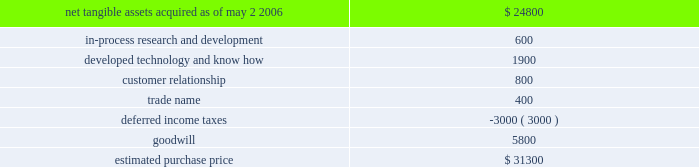Hologic , inc .
Notes to consolidated financial statements ( continued ) ( in thousands , except per share data ) its supply chain and improve manufacturing margins .
The combination of the companies should also facilitate further manufacturing efficiencies and accelerate research and development of new detector products .
Aeg was a privately held group of companies headquartered in warstein , germany , with manufacturing operations in germany , china and the united states .
The aggregate purchase price for aeg was approximately $ 31300 ( subject to adjustment ) consisting of eur $ 24100 in cash and 110 shares of hologic common stock valued at $ 5300 , and approximately $ 1900 for acquisition related fees and expenses .
The company determined the fair value of the shares issued in connection with the acquisition in accordance with eitf issue no .
99-12 , determination of the measurement date for the market price of acquirer securities issued in a purchase business combination .
These 110 shares were subject to contingent put options pursuant to which the holders had the option to resell the shares to the company during a period of one year following the completion of the acquisition if the closing price of the company 2019s stock falls and remains below a threshold price .
The put options were never exercised and expired on may 2 , 2007 .
The acquisition also provided for a one-year earn out of eur 1700 ( approximately $ 2000 usd ) which was payable in cash if aeg calendar year 2006 earnings , as defined , exceeded a pre-determined amount .
Aeg 2019s 2006 earnings did not exceed such pre-determined amounts and no payment was made .
The components and allocation of the purchase price , consists of the following approximate amounts: .
The company implemented a plan to restructure certain of aeg 2019s historical activities .
The company originally recorded a liability of approximately $ 2100 in accordance with eitf issue no .
95-3 , recognition of liabilities in connection with a purchase business combination , related to the termination of certain employees under this plan .
Upon completion of the plan in fiscal 2007 the company reduced this liability by approximately $ 241 with a corresponding reduction in goodwill .
All amounts have been paid as of september 29 , 2007 .
As part of the aeg acquisition the company acquired a minority interest in the equity securities of a private german company .
The company estimated the fair value of these securities to be approximately $ 1400 in its original purchase price allocation .
During the year ended september 29 , 2007 , the company sold these securities for proceeds of approximately $ 2150 .
The difference of approximately $ 750 between the preliminary fair value estimate and proceeds upon sale has been recorded as a reduction of goodwill .
The final purchase price allocations were completed within one year of the acquisition and the adjustments did not have a material impact on the company 2019s financial position or results of operations .
There have been no other material changes to the purchase price allocation as disclosed in the company 2019s form 10-k for the year ended september 30 , 2006 .
As part of the purchase price allocation , all intangible assets that were a part of the acquisition were identified and valued .
It was determined that only customer relationship , trade name , developed technology and know how and in-process research and development had separately identifiable values .
The fair value of these intangible assets was determined through the application of the income approach .
Customer relationship represents aeg 2019s high dependency on a small number of large accounts .
Aeg markets its products through distributors as well as directly to its own customers .
Trade name represents aeg 2019s product names that the company intends to continue to use .
Developed technology and know how represents currently marketable .
What portion of the estimated purchase price is dedicated to goodwill? 
Computations: (5800 / 31300)
Answer: 0.1853. 